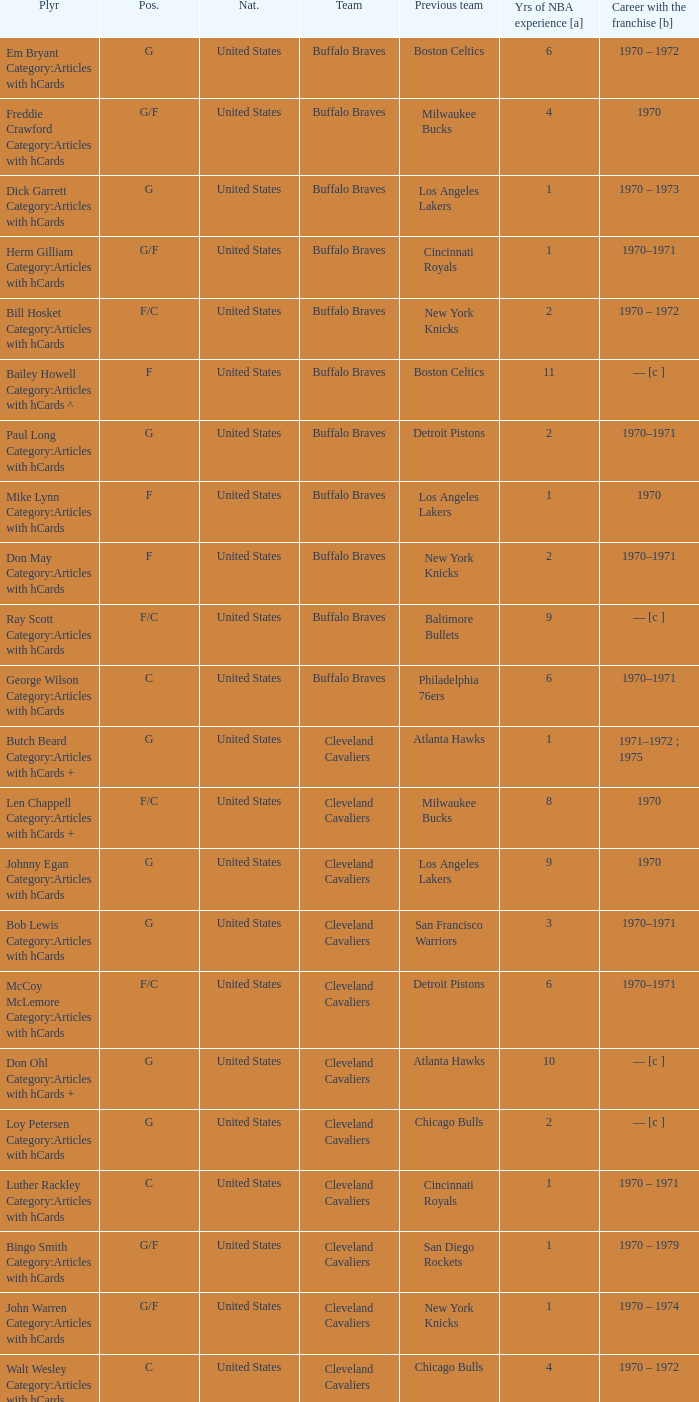How many years of NBA experience does the player who plays position g for the Portland Trail Blazers? 2.0. 